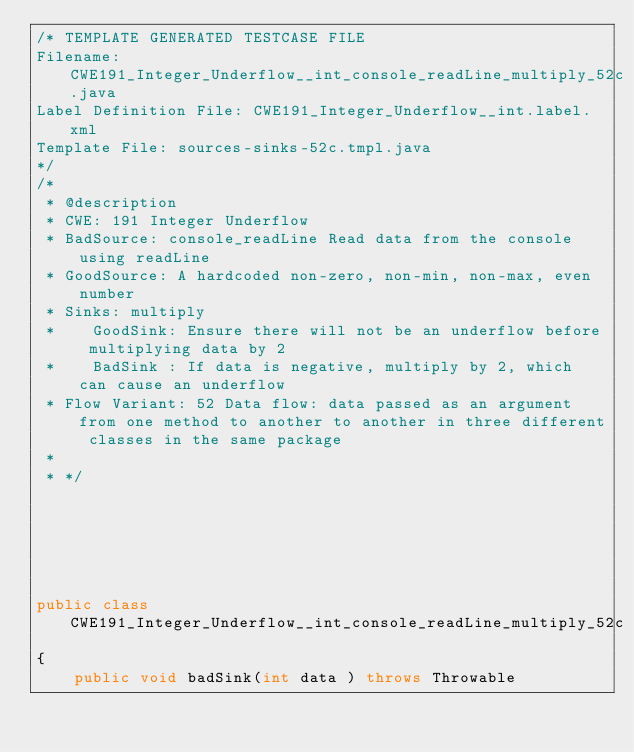<code> <loc_0><loc_0><loc_500><loc_500><_Java_>/* TEMPLATE GENERATED TESTCASE FILE
Filename: CWE191_Integer_Underflow__int_console_readLine_multiply_52c.java
Label Definition File: CWE191_Integer_Underflow__int.label.xml
Template File: sources-sinks-52c.tmpl.java
*/
/*
 * @description
 * CWE: 191 Integer Underflow
 * BadSource: console_readLine Read data from the console using readLine
 * GoodSource: A hardcoded non-zero, non-min, non-max, even number
 * Sinks: multiply
 *    GoodSink: Ensure there will not be an underflow before multiplying data by 2
 *    BadSink : If data is negative, multiply by 2, which can cause an underflow
 * Flow Variant: 52 Data flow: data passed as an argument from one method to another to another in three different classes in the same package
 *
 * */






public class CWE191_Integer_Underflow__int_console_readLine_multiply_52c
{
    public void badSink(int data ) throws Throwable</code> 